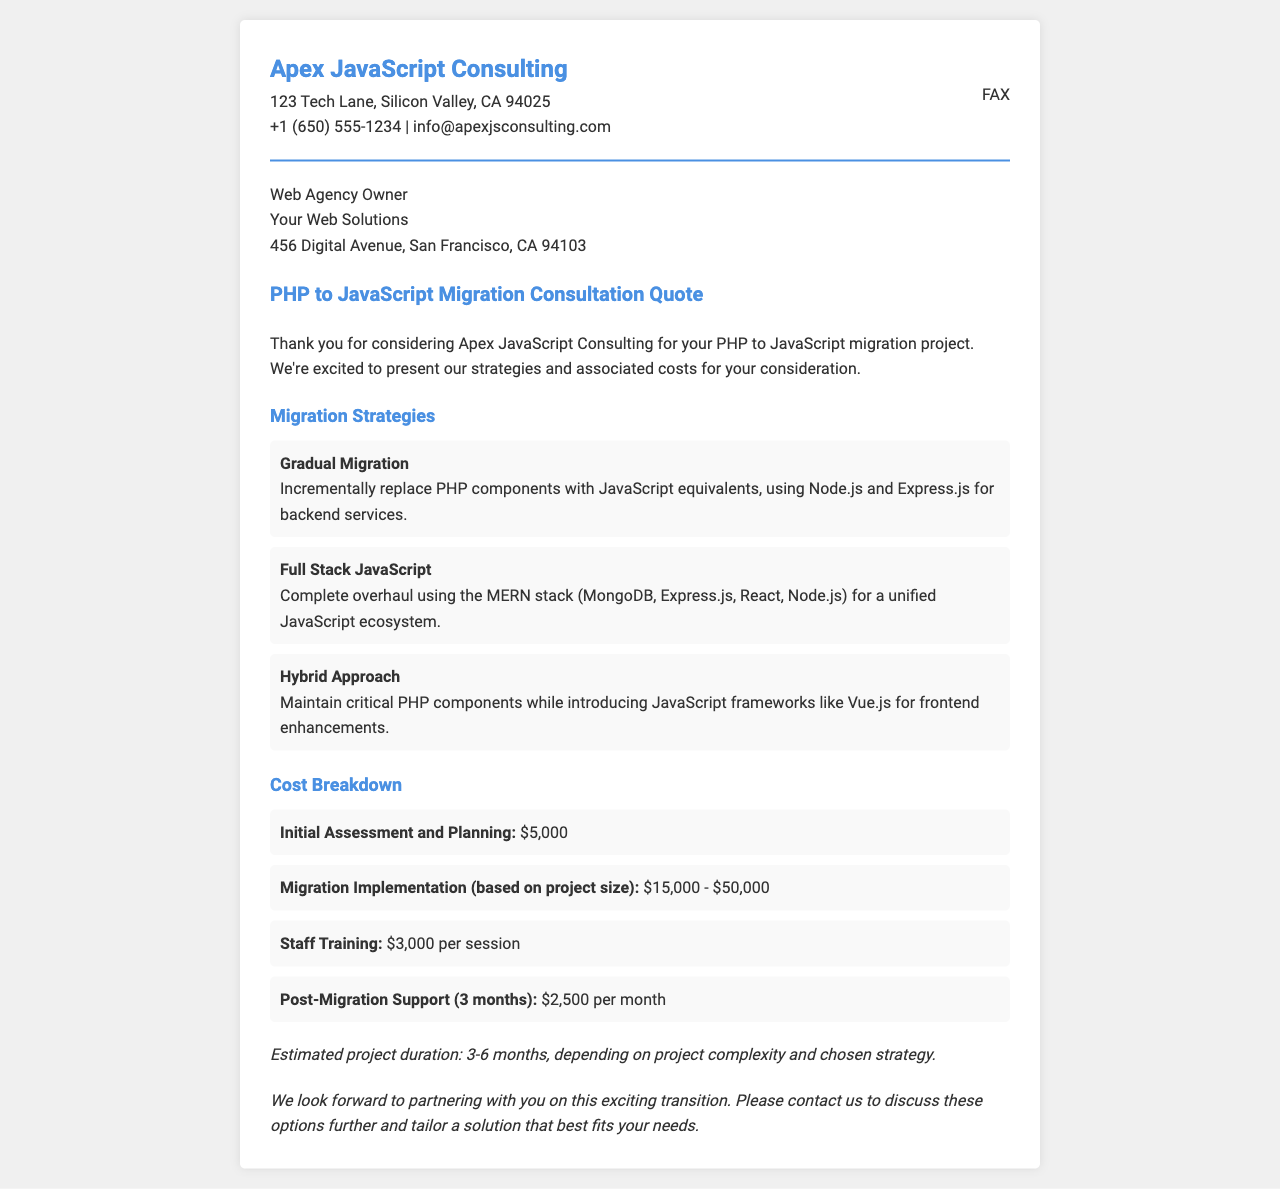What is the name of the consulting firm? The document states that the consulting firm is Apex JavaScript Consulting.
Answer: Apex JavaScript Consulting What is the cost of the initial assessment and planning? The document lists the cost of the initial assessment and planning as $5,000.
Answer: $5,000 What migration strategy involves a complete overhaul? The strategy involving a complete overhaul is referred to as the Full Stack JavaScript approach.
Answer: Full Stack JavaScript How much is the post-migration support per month? The post-migration support is stated to be $2,500 per month in the document.
Answer: $2,500 What is the estimated project duration? The document provides an estimated project duration of 3-6 months depending on complexity.
Answer: 3-6 months What is the name of the web agency owner’s company? The document mentions the web agency owner’s company as Your Web Solutions.
Answer: Your Web Solutions What is the staff training cost per session? The document specifies the cost of staff training as $3,000 per session.
Answer: $3,000 Which document section describes the migration strategies? The migration strategies are described in the section titled Migration Strategies.
Answer: Migration Strategies What is the maximum cost for migration implementation? The maximum cost for migration implementation is listed as $50,000 in the document.
Answer: $50,000 